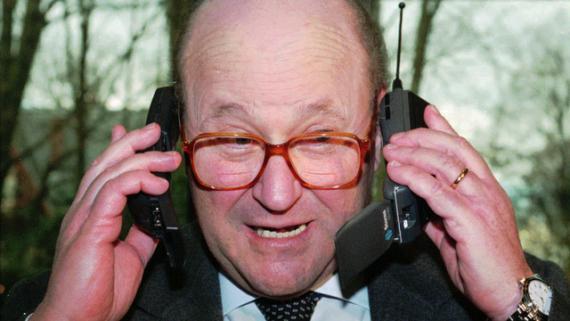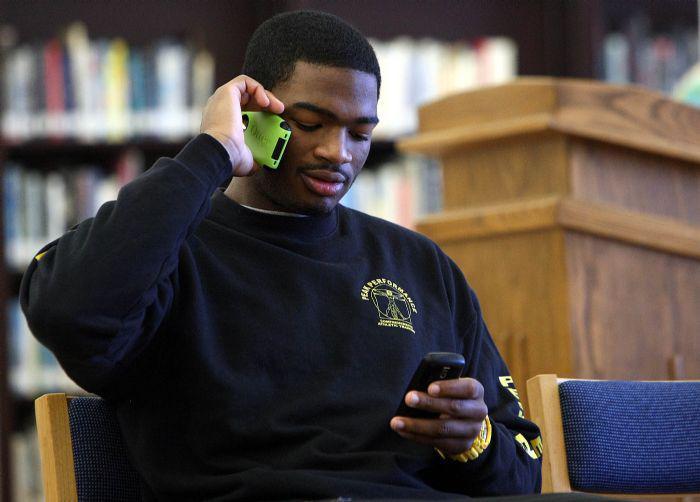The first image is the image on the left, the second image is the image on the right. For the images displayed, is the sentence "Three or more humans are visible." factually correct? Answer yes or no. No. The first image is the image on the left, the second image is the image on the right. Given the left and right images, does the statement "A person is holding two phones in the right image." hold true? Answer yes or no. Yes. 